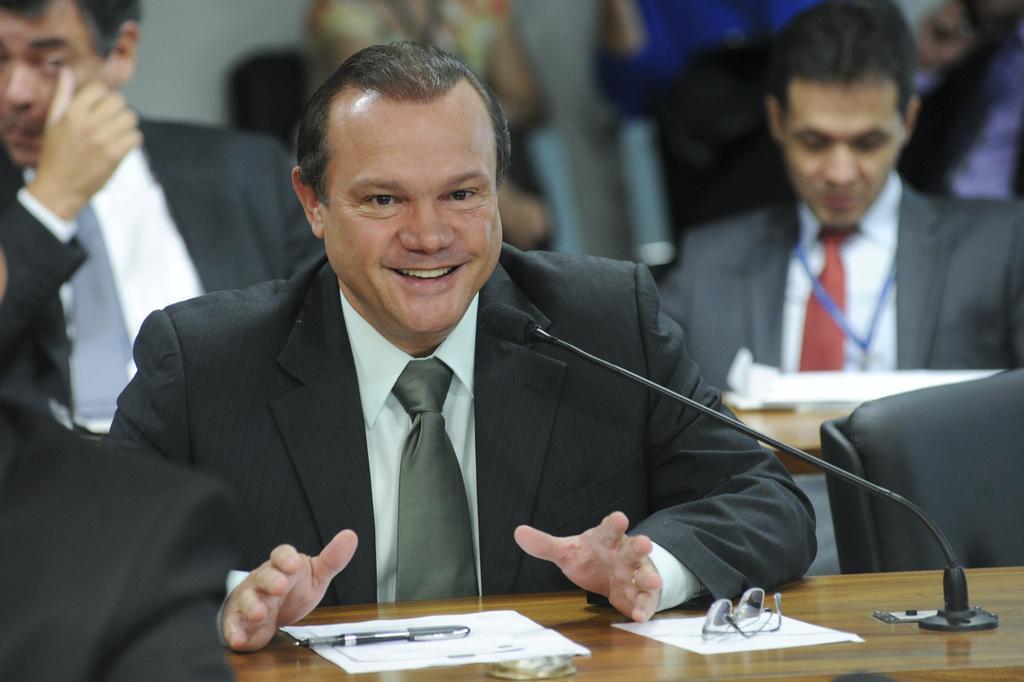Please provide a concise description of this image. As we can see in the image there are few people sitting on chairs and there is a mike on table. 